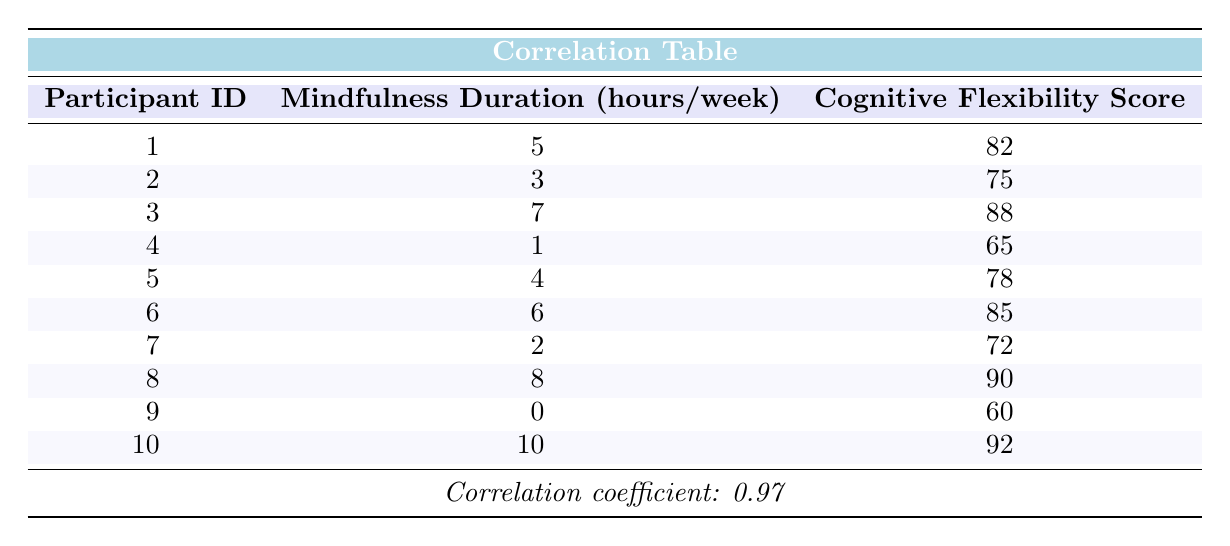What is the cognitive flexibility score of participant 5? From the table, we can locate participant 5 in the row corresponding to their ID, which indicates that their cognitive flexibility score is 78.
Answer: 78 What is the mindfulness duration for participant 10? Looking at the table, participant 10 is listed as having a mindfulness duration of 10 hours per week.
Answer: 10 What is the average cognitive flexibility score of all participants? We calculate the average by summing all the cognitive flexibility scores: (82 + 75 + 88 + 65 + 78 + 85 + 72 + 90 + 60 + 92) =  91, and dividing by the number of participants (10). Thus, the average score is 81.
Answer: 81 Is there a correlation between mindfulness duration and cognitive flexibility scores? The table provides a correlation coefficient of 0.97, which indicates a strong positive correlation between the two variables.
Answer: Yes How many participants have a cognitive flexibility score above 80? We can see that the participants with scores above 80 are participant 1 (82), 3 (88), 6 (85), 8 (90), and 10 (92), which totals to 5 participants.
Answer: 5 What is the difference in cognitive flexibility score between the participant with the highest mindfulness duration and the one with the lowest? The participant with the highest mindfulness duration is participant 10 with 92, and the one with the lowest is participant 9 with 60. The difference is calculated as 92 - 60 = 32.
Answer: 32 If a participant practices mindfulness for 4 hours per week, what is the likelihood of having a cognitive flexibility score of 80 or more, based on the data? The participants who practiced for 4 hours are participant 5 (78) and no others explicitly, and they do not meet the score of 80 or above. Based on the data provided, no participant practicing for that duration meets the score threshold.
Answer: No What is the total mindfulness duration of all participants combined? By summing the mindfulness durations, we have (5 + 3 + 7 + 1 + 4 + 6 + 2 + 8 + 0 + 10) = 46.
Answer: 46 Which participant has the highest cognitive flexibility score, and what is that score? Participant 10 has the highest cognitive flexibility score listed at 92.
Answer: Participant 10, 92 